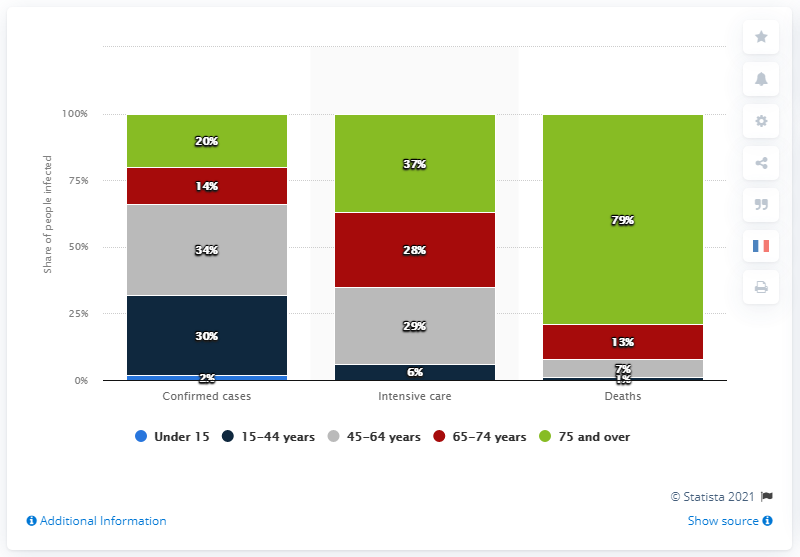Highlight a few significant elements in this photo. According to recent data, a significant proportion of individuals affected by the COVID-19 coronavirus were between the ages of 45 and 64. Specifically, 34% of those affected fell within this age range. 